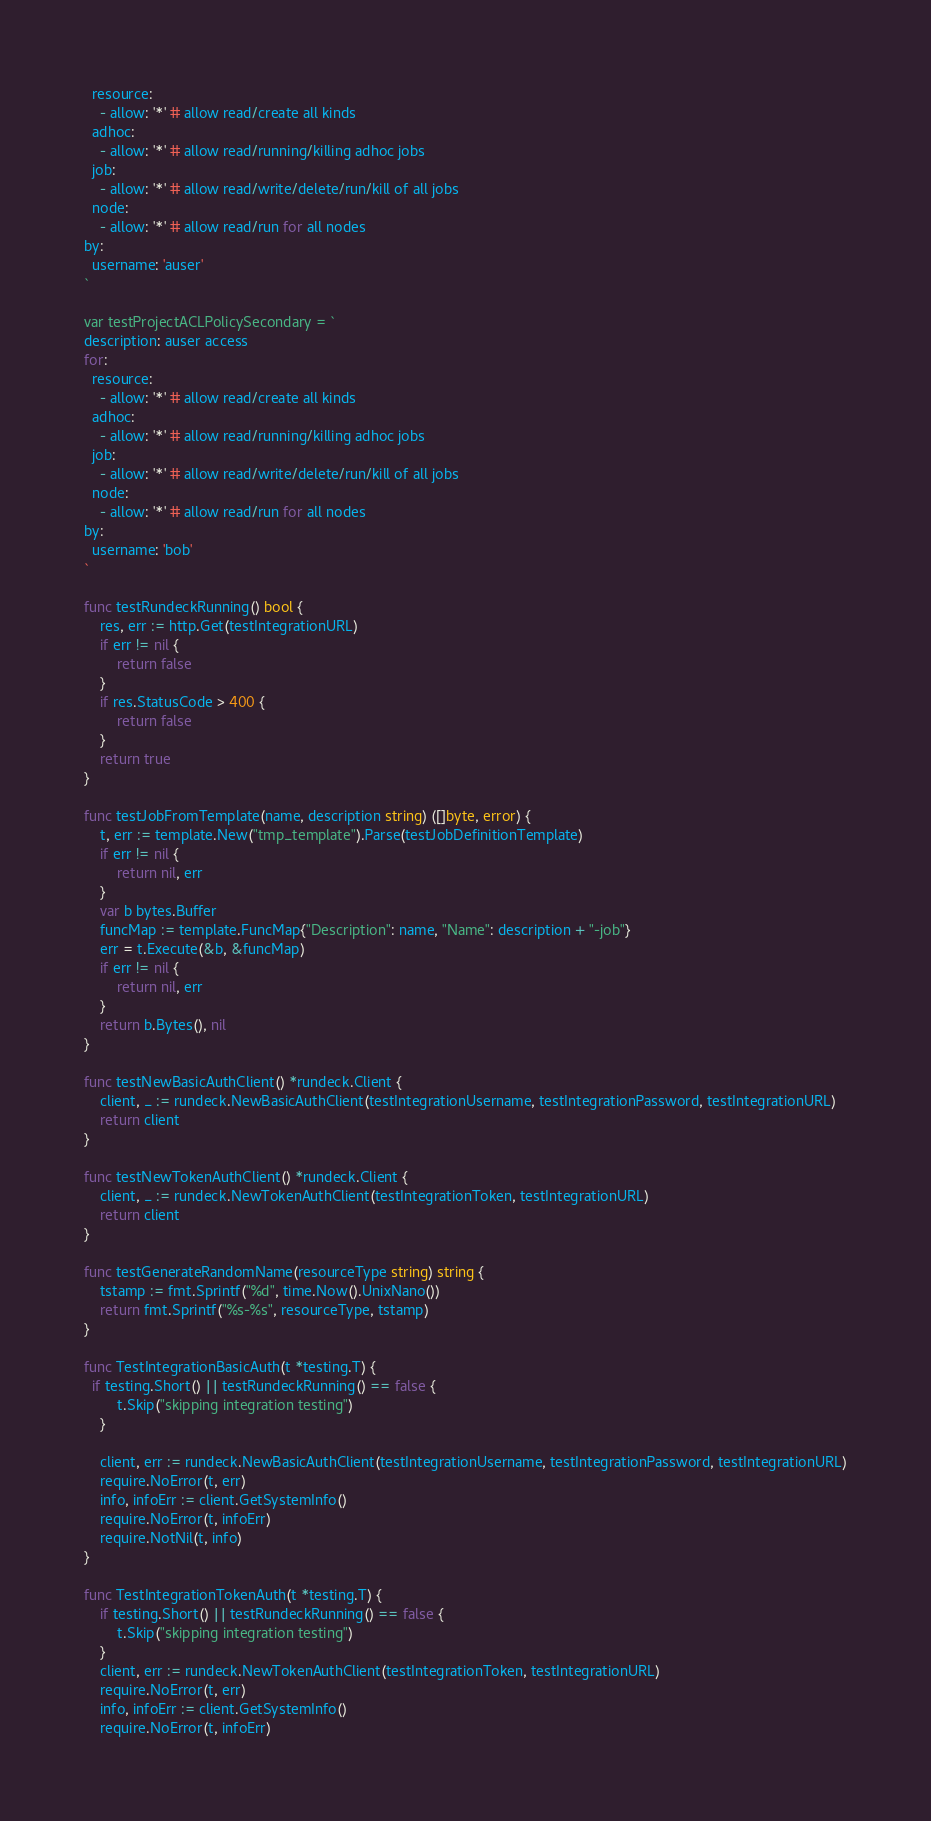<code> <loc_0><loc_0><loc_500><loc_500><_Go_>  resource:
    - allow: '*' # allow read/create all kinds
  adhoc:
    - allow: '*' # allow read/running/killing adhoc jobs
  job:
    - allow: '*' # allow read/write/delete/run/kill of all jobs
  node:
    - allow: '*' # allow read/run for all nodes
by:
  username: 'auser'
`

var testProjectACLPolicySecondary = `
description: auser access
for:
  resource:
    - allow: '*' # allow read/create all kinds
  adhoc:
    - allow: '*' # allow read/running/killing adhoc jobs
  job:
    - allow: '*' # allow read/write/delete/run/kill of all jobs
  node:
    - allow: '*' # allow read/run for all nodes
by:
  username: 'bob'
`

func testRundeckRunning() bool {
	res, err := http.Get(testIntegrationURL)
	if err != nil {
		return false
	}
	if res.StatusCode > 400 {
		return false
	}
	return true
}

func testJobFromTemplate(name, description string) ([]byte, error) {
	t, err := template.New("tmp_template").Parse(testJobDefinitionTemplate)
	if err != nil {
		return nil, err
	}
	var b bytes.Buffer
	funcMap := template.FuncMap{"Description": name, "Name": description + "-job"}
	err = t.Execute(&b, &funcMap)
	if err != nil {
		return nil, err
	}
	return b.Bytes(), nil
}

func testNewBasicAuthClient() *rundeck.Client {
	client, _ := rundeck.NewBasicAuthClient(testIntegrationUsername, testIntegrationPassword, testIntegrationURL)
	return client
}

func testNewTokenAuthClient() *rundeck.Client {
	client, _ := rundeck.NewTokenAuthClient(testIntegrationToken, testIntegrationURL)
	return client
}

func testGenerateRandomName(resourceType string) string {
	tstamp := fmt.Sprintf("%d", time.Now().UnixNano())
	return fmt.Sprintf("%s-%s", resourceType, tstamp)
}

func TestIntegrationBasicAuth(t *testing.T) {
  if testing.Short() || testRundeckRunning() == false {
		t.Skip("skipping integration testing")
	}

	client, err := rundeck.NewBasicAuthClient(testIntegrationUsername, testIntegrationPassword, testIntegrationURL)
	require.NoError(t, err)
	info, infoErr := client.GetSystemInfo()
	require.NoError(t, infoErr)
	require.NotNil(t, info)
}

func TestIntegrationTokenAuth(t *testing.T) {
	if testing.Short() || testRundeckRunning() == false {
		t.Skip("skipping integration testing")
	}
	client, err := rundeck.NewTokenAuthClient(testIntegrationToken, testIntegrationURL)
	require.NoError(t, err)
	info, infoErr := client.GetSystemInfo()
	require.NoError(t, infoErr)</code> 